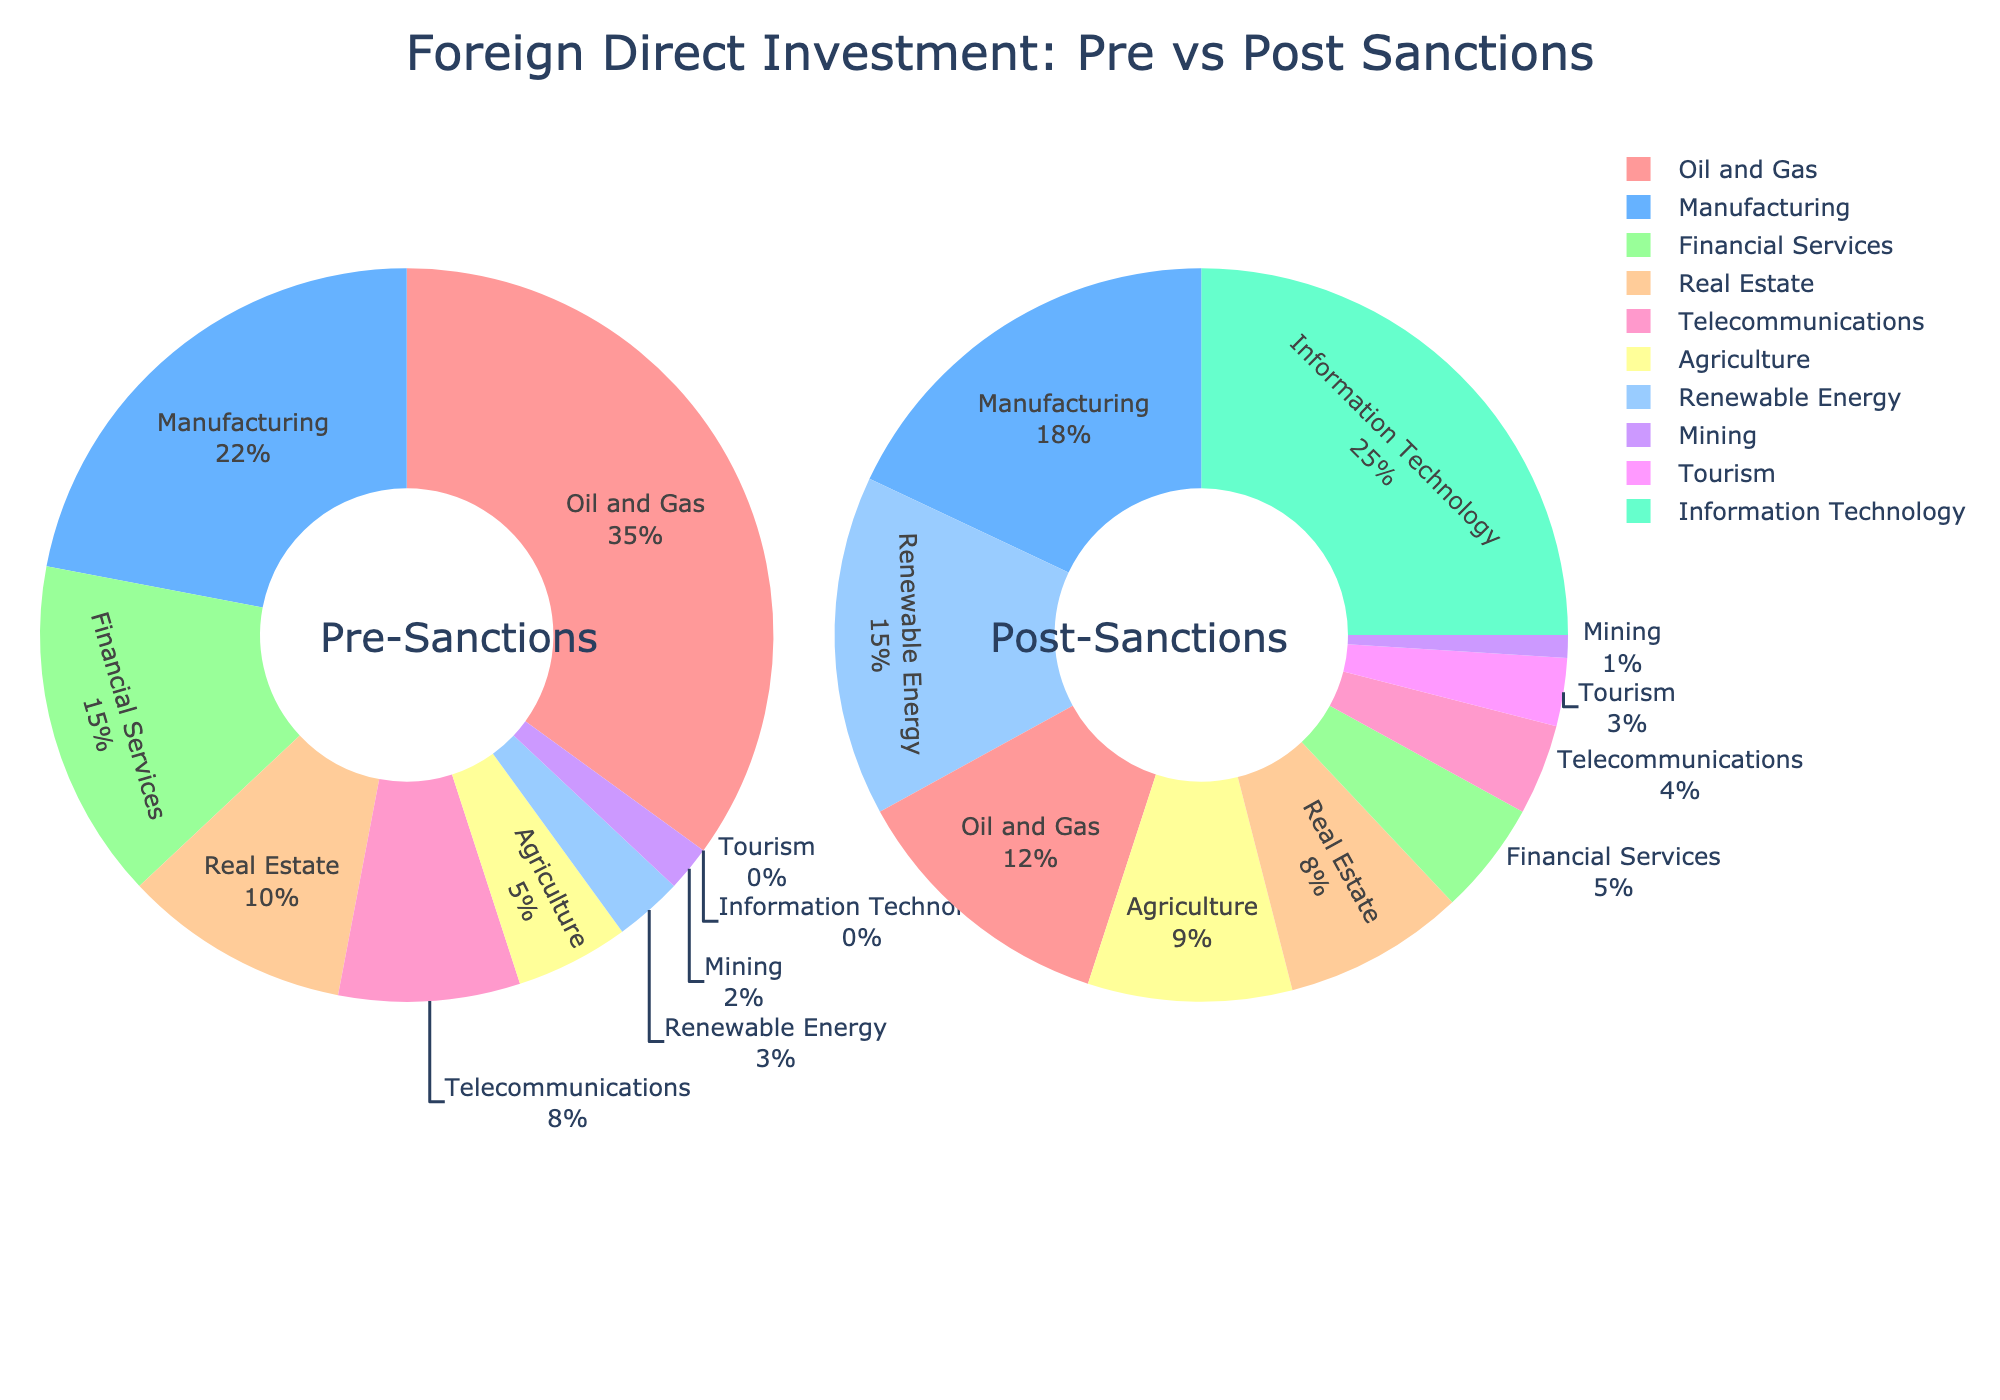What's the sector with the largest decline in FDI percentage from pre- to post-sanctions? By comparing the decline in percentages for all sectors, Oil and Gas decreases the most from 35% to 12%.
Answer: Oil and Gas Which sector showed a significant increase in its FDI percentage post-sanctions while having no share pre-sanctions? Information Technology had 0% share pre-sanctions and now holds 25% post-sanctions, indicating a significant increase.
Answer: Information Technology What is the total percentage share of sectors with increased FDI post-sanctions? Summing up increases: Manufacturing (18% - 22%) = -4%, Real Estate (8% - 10%) = -2%, Agriculture (9% - 5%) = 4%, Renewable Energy (15% - 3%) = 12%, Tourism (3% - 0%) = 3%, Information Technology (25% - 0%) = 25%. Total = 4 + 12 + 3 + 25 = 44%.
Answer: 44% Compare the share of FDI in Financial Services between pre- and post-sanctions. Financial Services' share dropped from 15% to 5%, indicating a decline.
Answer: It declined Which sectors have a lesser share of FDI post-sanctions compared to pre-sanctions? By comparing each sector's values, Oil and Gas, Financial Services, Real Estate, Telecommunications, and Mining have lesser shares post-sanctions.
Answer: Oil and Gas, Financial Services, Real Estate, Telecommunications, Mining What is the combined FDI percentage share of the top two sectors post-sanctions? The top two sectors post-sanctions are Information Technology (25%) and Renewable Energy (15%). Combined, they make 25% + 15% = 40%.
Answer: 40% How does the FDI percentage in Agricultural change from pre- to post-sanctions? The FDI percentage in Agriculture increases from 5% to 9%. The change is 9% - 5% = 4%.
Answer: It increased by 4% What is the difference in percentage share between the Oil and Gas sector pre-sanctions and the Information Technology sector post-sanctions? The percentage in Oil and Gas pre-sanctions is 35% and Information Technology post-sanctions is 25%, so the difference is 35% - 25% = 10%.
Answer: 10% Compare the combined FDI in Financial Services and Telecommunications pre- and post-sanctions. Pre-sanctions: Financial Services (15%) + Telecommunications (8%) = 23%. Post-sanctions: Financial Services (5%) + Telecommunications (4%) = 9%. The FDI has decreased.
Answer: It decreased 